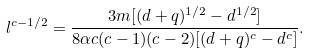<formula> <loc_0><loc_0><loc_500><loc_500>l ^ { c - 1 / 2 } = \frac { 3 m [ ( d + q ) ^ { 1 / 2 } - d ^ { 1 / 2 } ] } { 8 \alpha c ( c - 1 ) ( c - 2 ) [ ( d + q ) ^ { c } - d ^ { c } ] } .</formula> 